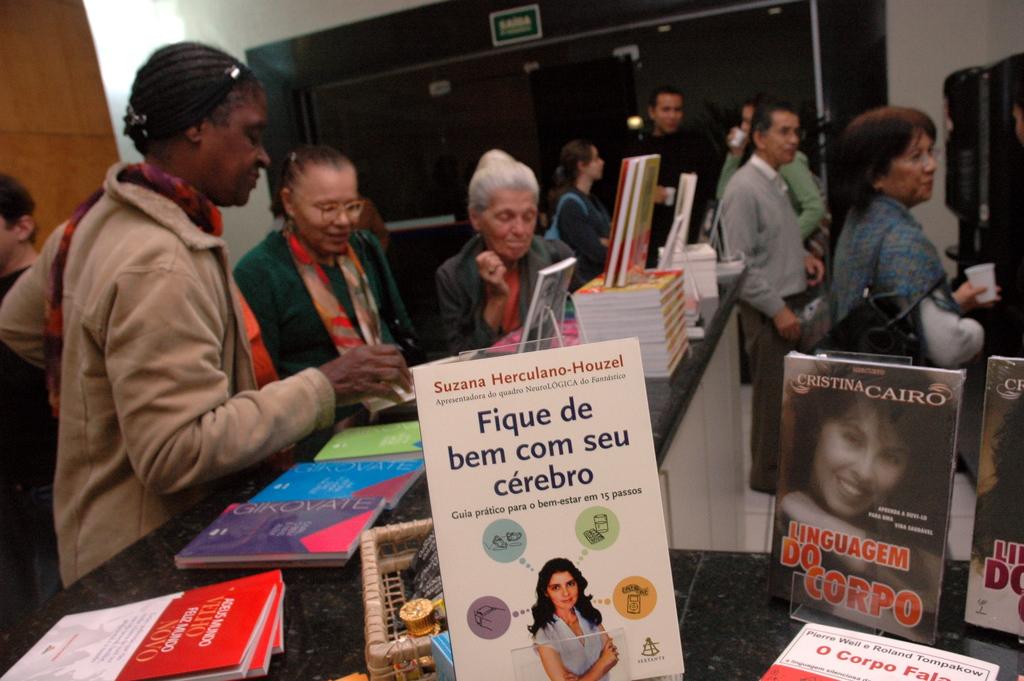What book is that?
Provide a short and direct response. Fique de bem com seu cerebro. 